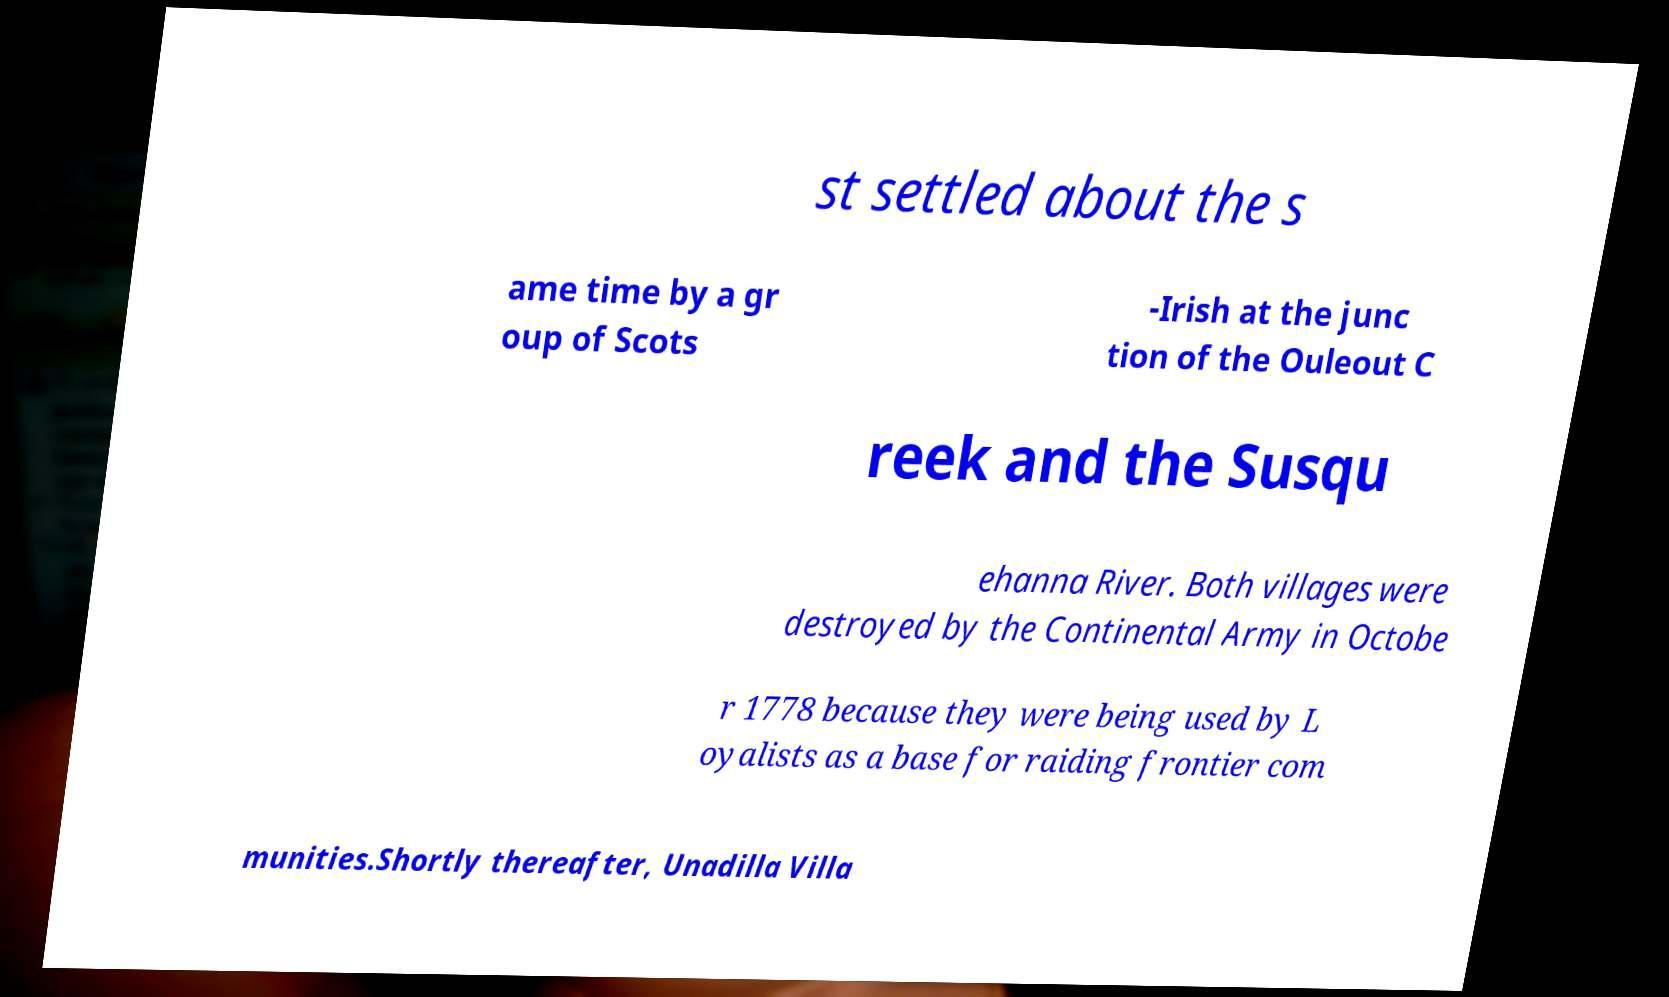There's text embedded in this image that I need extracted. Can you transcribe it verbatim? st settled about the s ame time by a gr oup of Scots -Irish at the junc tion of the Ouleout C reek and the Susqu ehanna River. Both villages were destroyed by the Continental Army in Octobe r 1778 because they were being used by L oyalists as a base for raiding frontier com munities.Shortly thereafter, Unadilla Villa 